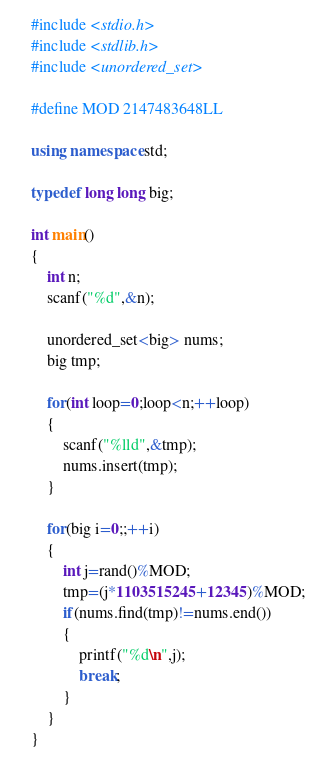<code> <loc_0><loc_0><loc_500><loc_500><_C++_>#include <stdio.h>
#include <stdlib.h>
#include <unordered_set>

#define MOD 2147483648LL

using namespace std;

typedef long long big;

int main()
{
    int n;
    scanf("%d",&n);

    unordered_set<big> nums;
    big tmp;
    
    for(int loop=0;loop<n;++loop)
    {
        scanf("%lld",&tmp);
        nums.insert(tmp);
    }

    for(big i=0;;++i)
    {
        int j=rand()%MOD;
        tmp=(j*1103515245+12345)%MOD;
        if(nums.find(tmp)!=nums.end())
        {
            printf("%d\n",j);
            break;
        }
    }
}
</code> 